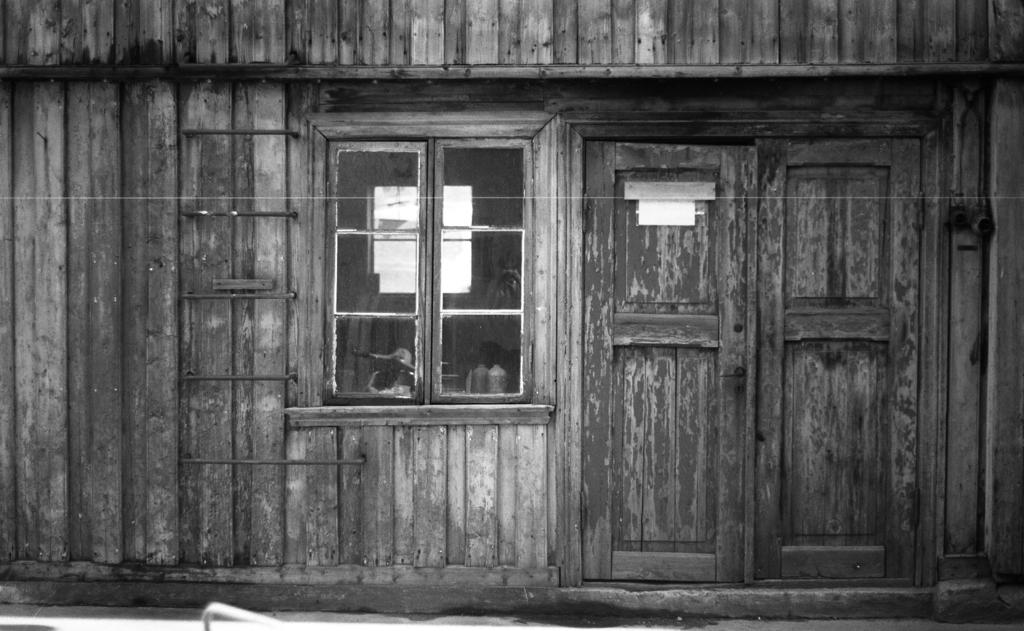What is the color scheme of the image? The image is black and white. What type of house is depicted in the image? The image depicts a wooden house. What is the purpose of the ladder in the image? The ladder's purpose is not explicitly stated, but it could be used for reaching the upper levels of the house or for maintenance purposes. What can be seen on the window glass in the image? There is a reflection on the window glass. What is the primary entrance to the house in the image? There is a door in the image, which is likely the primary entrance. Can you describe any additional objects visible in the image? There are additional objects visible in the image, but their specific details are not mentioned in the provided facts. How many chickens are visible in the image? There are no chickens present in the image. What type of clam is being used to prop open the door in the image? There is no clam present in the image, and the door is not propped open. 